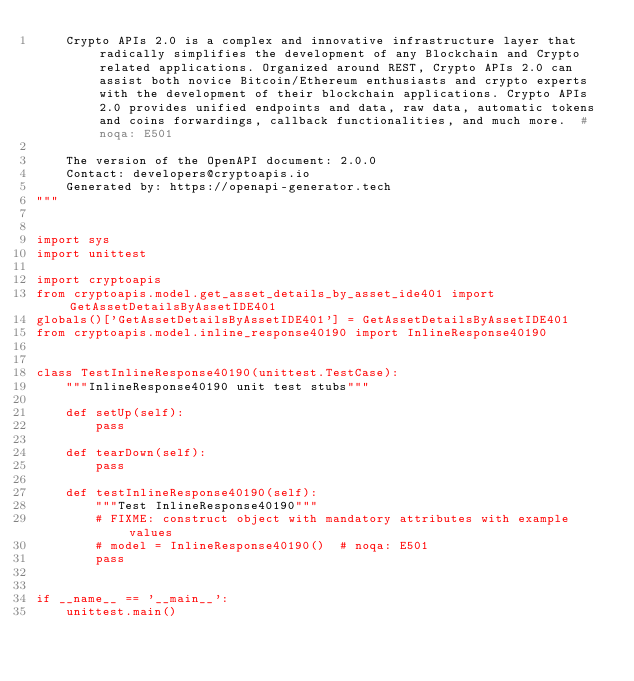Convert code to text. <code><loc_0><loc_0><loc_500><loc_500><_Python_>    Crypto APIs 2.0 is a complex and innovative infrastructure layer that radically simplifies the development of any Blockchain and Crypto related applications. Organized around REST, Crypto APIs 2.0 can assist both novice Bitcoin/Ethereum enthusiasts and crypto experts with the development of their blockchain applications. Crypto APIs 2.0 provides unified endpoints and data, raw data, automatic tokens and coins forwardings, callback functionalities, and much more.  # noqa: E501

    The version of the OpenAPI document: 2.0.0
    Contact: developers@cryptoapis.io
    Generated by: https://openapi-generator.tech
"""


import sys
import unittest

import cryptoapis
from cryptoapis.model.get_asset_details_by_asset_ide401 import GetAssetDetailsByAssetIDE401
globals()['GetAssetDetailsByAssetIDE401'] = GetAssetDetailsByAssetIDE401
from cryptoapis.model.inline_response40190 import InlineResponse40190


class TestInlineResponse40190(unittest.TestCase):
    """InlineResponse40190 unit test stubs"""

    def setUp(self):
        pass

    def tearDown(self):
        pass

    def testInlineResponse40190(self):
        """Test InlineResponse40190"""
        # FIXME: construct object with mandatory attributes with example values
        # model = InlineResponse40190()  # noqa: E501
        pass


if __name__ == '__main__':
    unittest.main()
</code> 